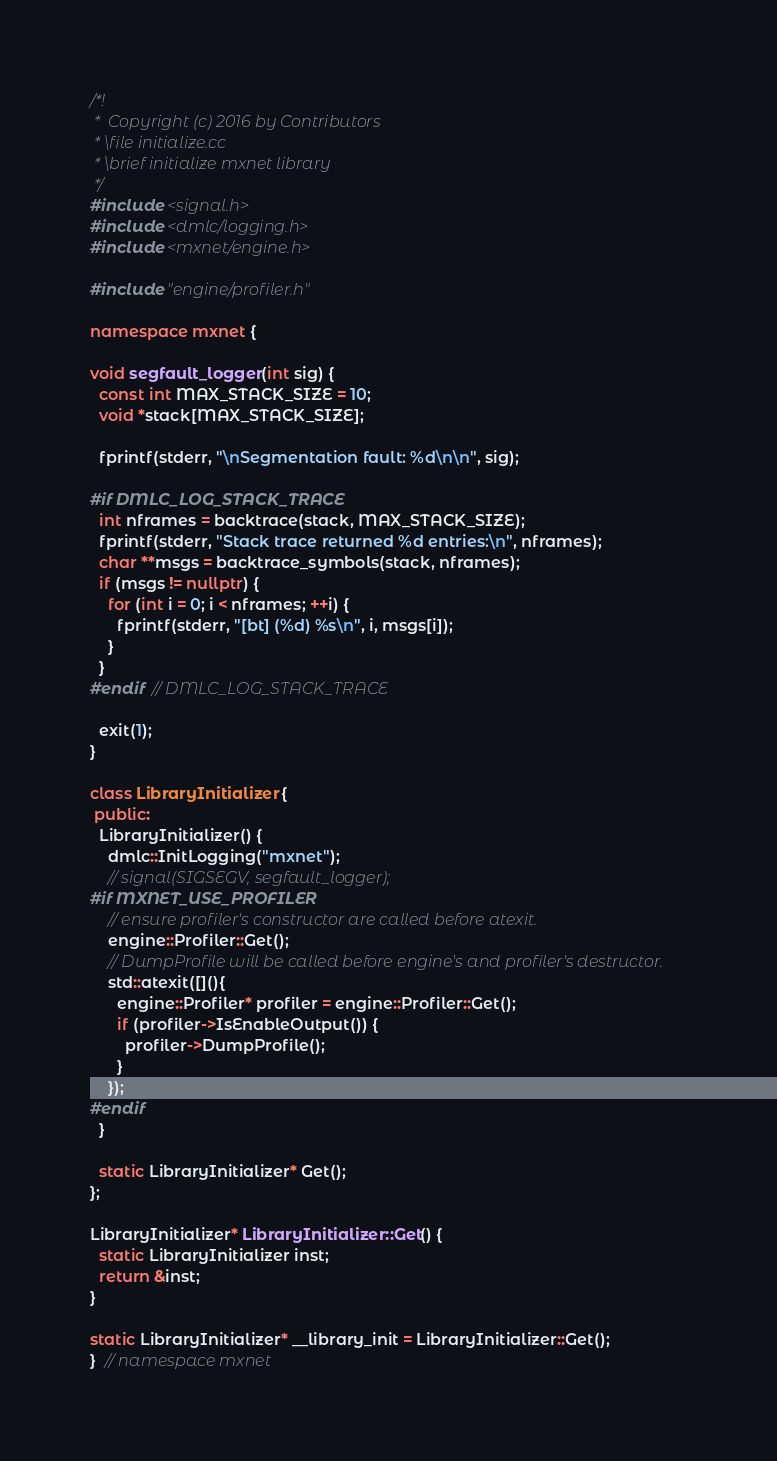Convert code to text. <code><loc_0><loc_0><loc_500><loc_500><_C++_>/*!
 *  Copyright (c) 2016 by Contributors
 * \file initialize.cc
 * \brief initialize mxnet library
 */
#include <signal.h>
#include <dmlc/logging.h>
#include <mxnet/engine.h>

#include "engine/profiler.h"

namespace mxnet {

void segfault_logger(int sig) {
  const int MAX_STACK_SIZE = 10;
  void *stack[MAX_STACK_SIZE];

  fprintf(stderr, "\nSegmentation fault: %d\n\n", sig);

#if DMLC_LOG_STACK_TRACE
  int nframes = backtrace(stack, MAX_STACK_SIZE);
  fprintf(stderr, "Stack trace returned %d entries:\n", nframes);
  char **msgs = backtrace_symbols(stack, nframes);
  if (msgs != nullptr) {
    for (int i = 0; i < nframes; ++i) {
      fprintf(stderr, "[bt] (%d) %s\n", i, msgs[i]);
    }
  }
#endif  // DMLC_LOG_STACK_TRACE

  exit(1);
}

class LibraryInitializer {
 public:
  LibraryInitializer() {
    dmlc::InitLogging("mxnet");
    // signal(SIGSEGV, segfault_logger);
#if MXNET_USE_PROFILER
    // ensure profiler's constructor are called before atexit.
    engine::Profiler::Get();
    // DumpProfile will be called before engine's and profiler's destructor.
    std::atexit([](){
      engine::Profiler* profiler = engine::Profiler::Get();
      if (profiler->IsEnableOutput()) {
        profiler->DumpProfile();
      }
    });
#endif
  }

  static LibraryInitializer* Get();
};

LibraryInitializer* LibraryInitializer::Get() {
  static LibraryInitializer inst;
  return &inst;
}

static LibraryInitializer* __library_init = LibraryInitializer::Get();
}  // namespace mxnet
</code> 